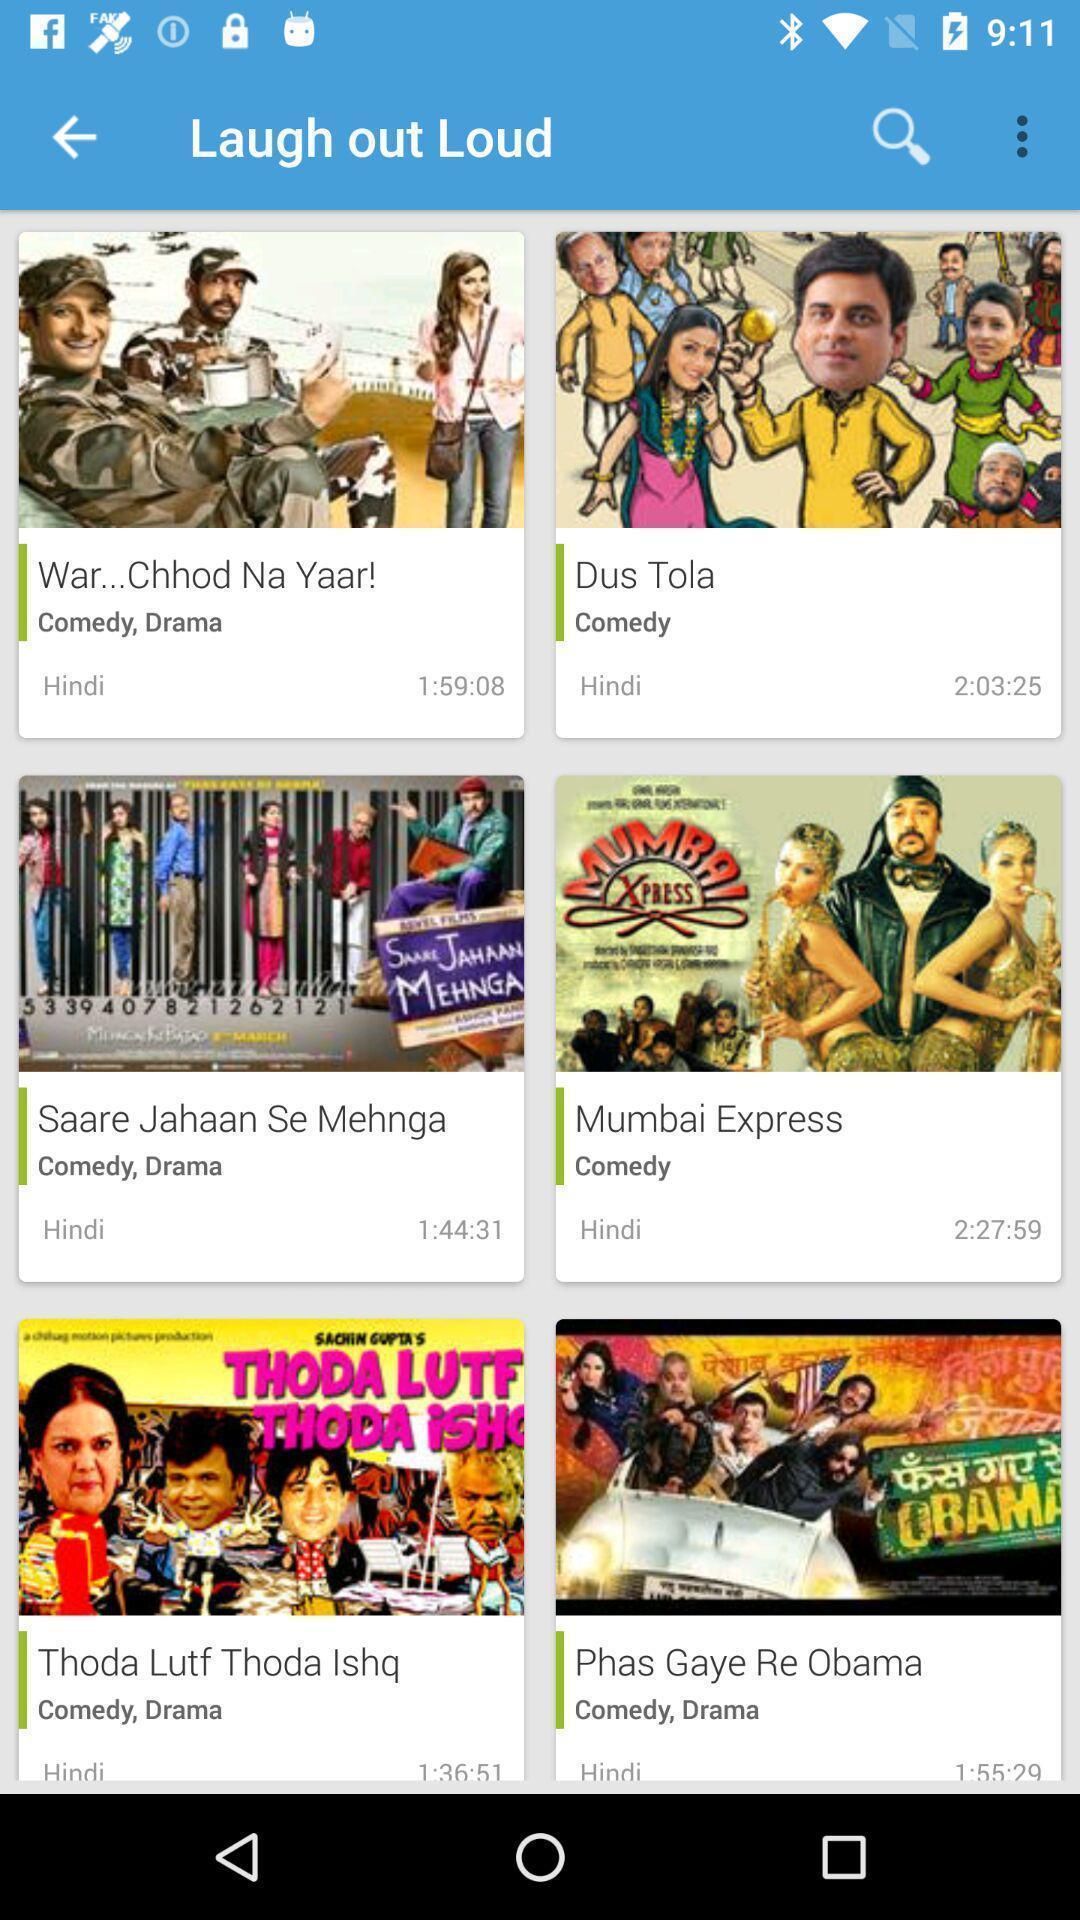Summarize the main components in this picture. Screen shows multiple options in an entertainment application. 